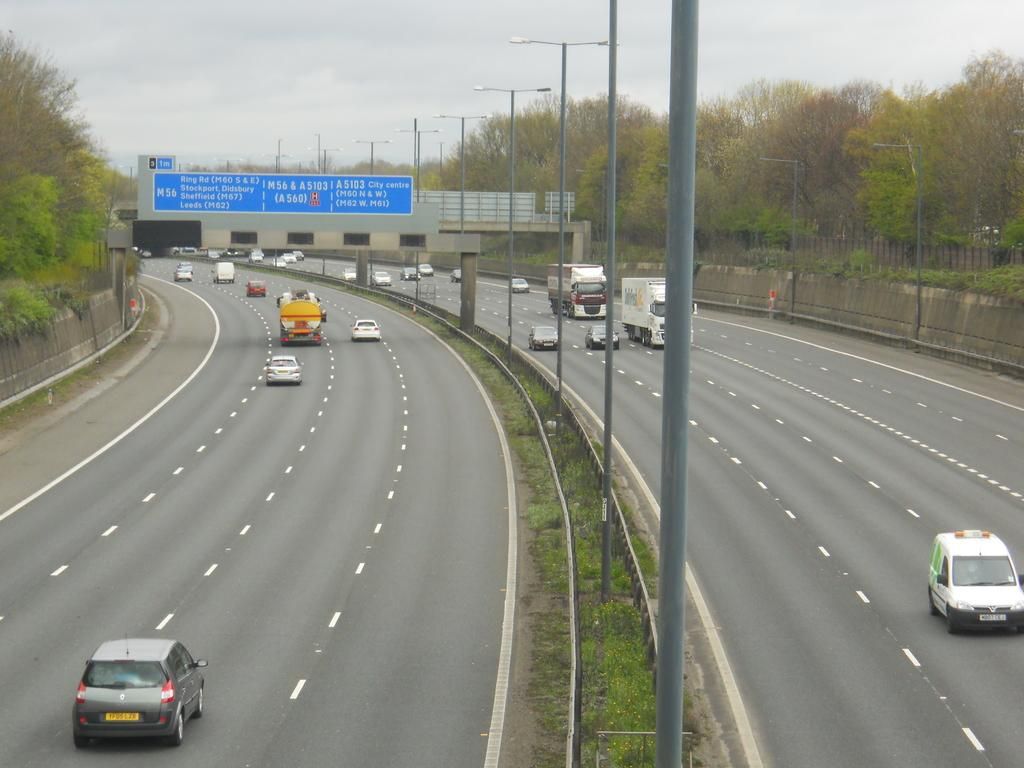What can be seen in the middle of the image? There are roads in the center of the image. What is happening on the roads? There are vehicles on the roads. What type of vegetation is present alongside the roads? There are trees on both sides of the roads. What type of lighting is present in the image? There are street lights in the image. Can you see any insects flying near the street lights in the image? There is no mention of insects in the image, so we cannot determine if any are present. 